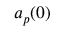Convert formula to latex. <formula><loc_0><loc_0><loc_500><loc_500>a _ { p } ( 0 )</formula> 